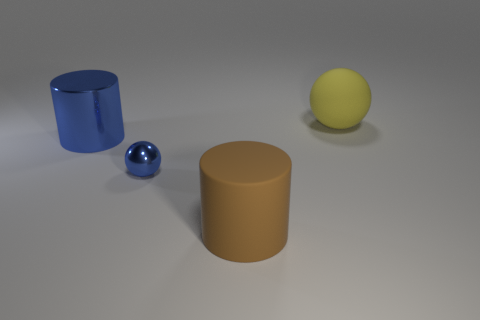Add 2 purple rubber things. How many objects exist? 6 Add 2 big brown matte objects. How many big brown matte objects are left? 3 Add 2 large metal cylinders. How many large metal cylinders exist? 3 Subtract 0 purple balls. How many objects are left? 4 Subtract all yellow matte balls. Subtract all blue cylinders. How many objects are left? 2 